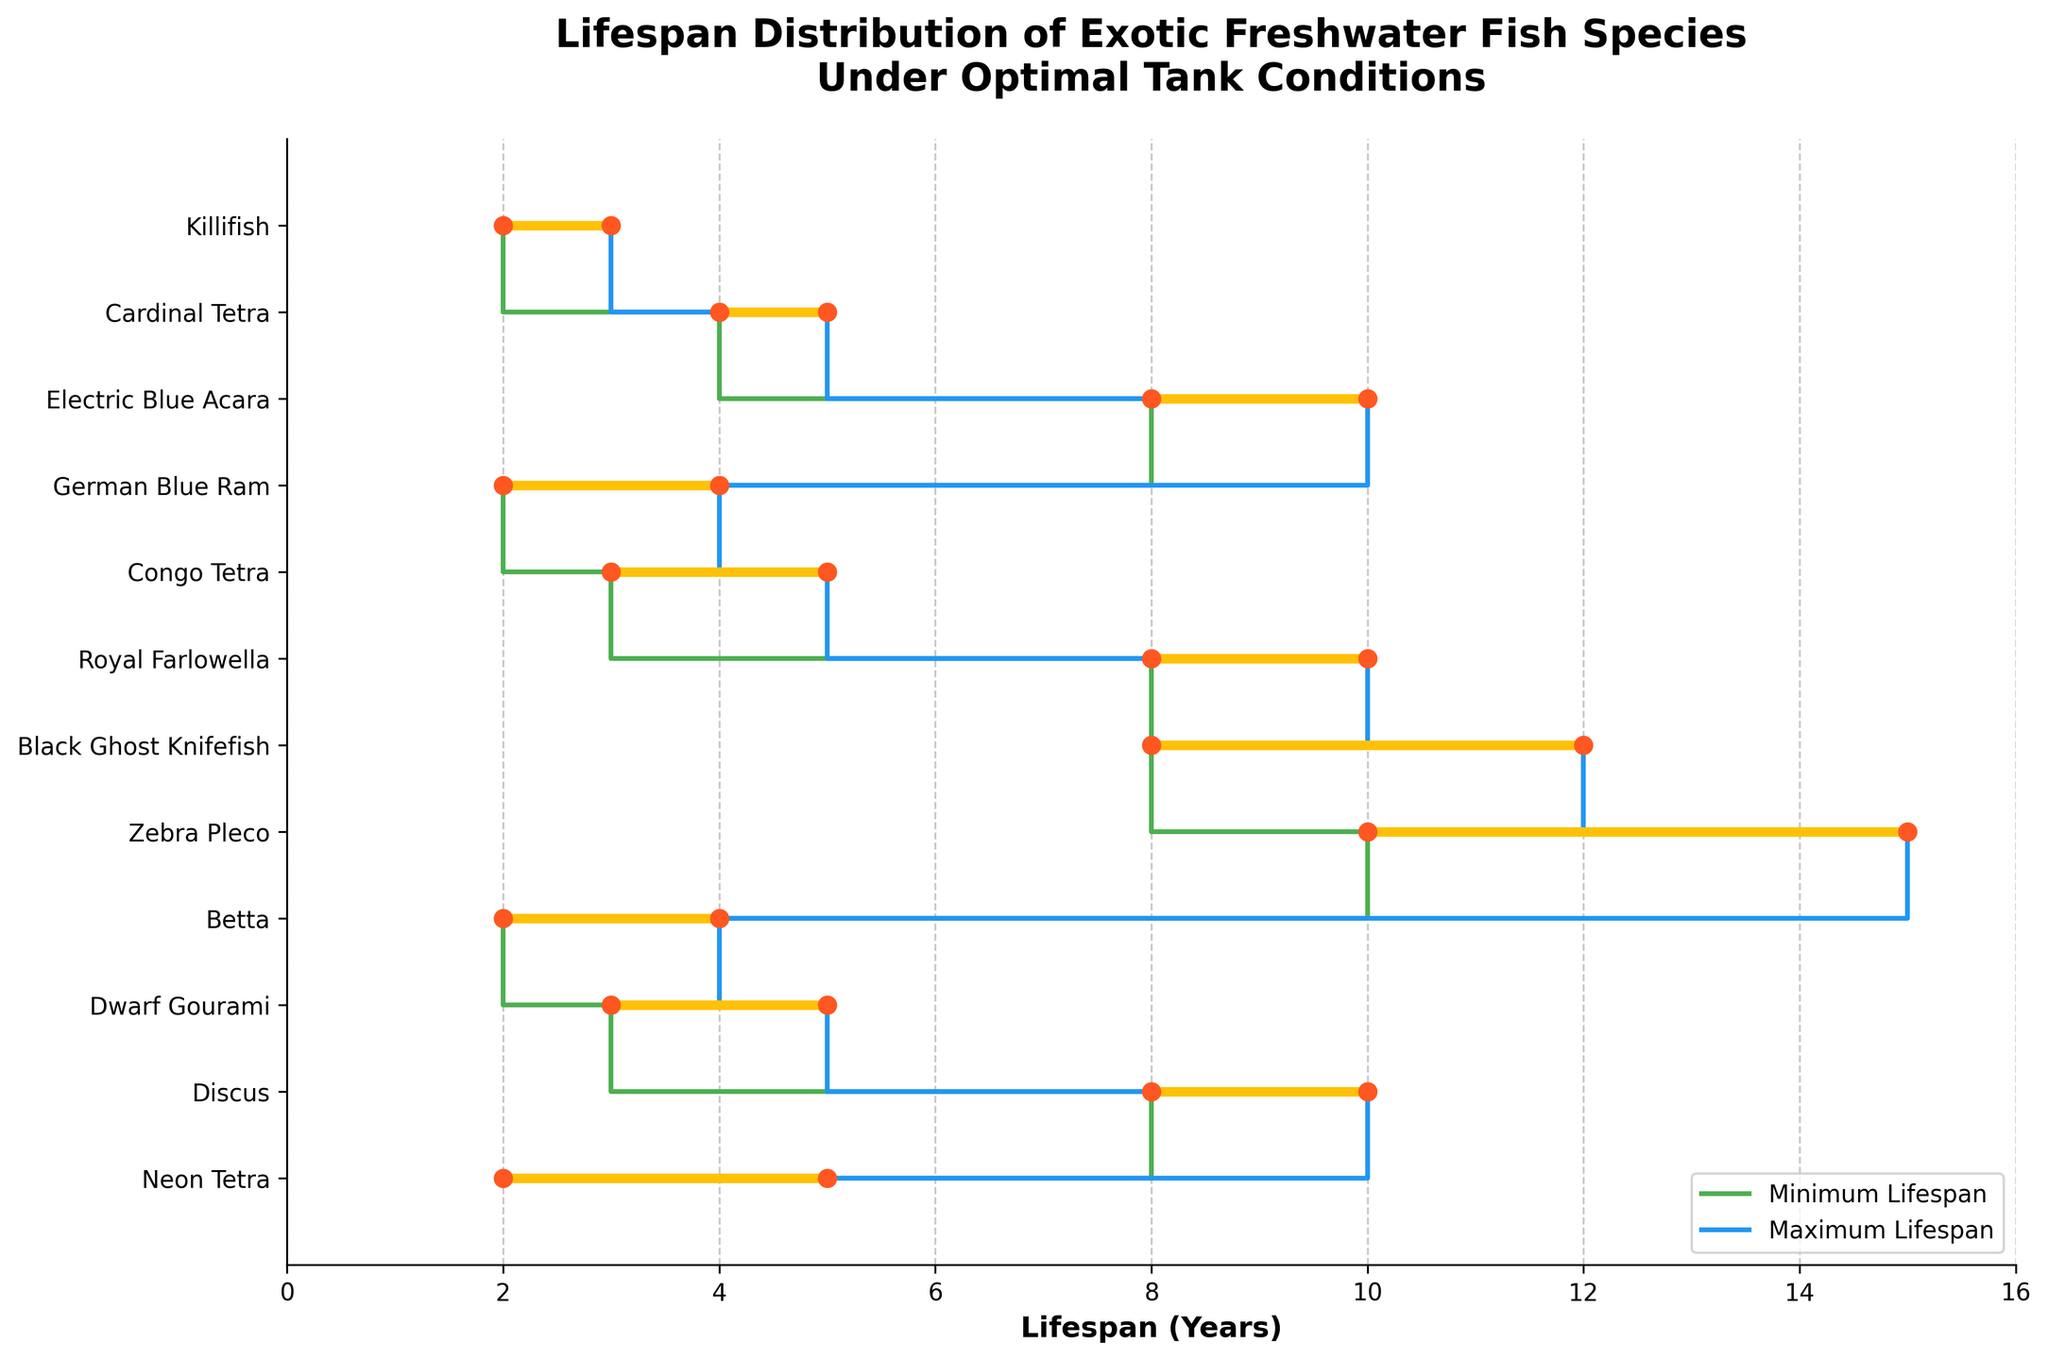What's the title of the plot? The title is displayed at the top of the plot and it reads 'Lifespan Distribution of Exotic Freshwater Fish Species Under Optimal Tank Conditions'. This provides context for the data being shown.
Answer: Lifespan Distribution of Exotic Freshwater Fish Species Under Optimal Tank Conditions How many species of fish are represented in the plot? Look at the number of labels on the y-axis. Each label corresponds to a different species of fish. There are 12 species listed.
Answer: 12 What is the maximum lifespan value shown on the x-axis? The x-axis represents the lifespan in years, and it has a numerical range. The highest value on this axis is 16.
Answer: 16 Which fish species has the shortest minimum lifespan? Check the green step line, which indicates the minimum lifespan for each species. Killifish has the shortest minimum lifespan, starting at 2 years.
Answer: Killifish Which fish species has the longest maximum lifespan? Observe the blue step line, representing the maximum lifespan. Zebra Pleco has the longest maximum lifespan, ending at 15 years.
Answer: Zebra Pleco What is the median of the minimum lifespans of all species? To find the median, list the minimum lifespans and find the middle value. The minimum lifespans are [2, 2, 2, 3, 3, 4, 8, 8, 8, 8, 10]. The median is the 6th value in this ordered list.
Answer: 4 How many species have a maximum lifespan of 10 years? Look at the species where the blue step ends at 10 years. Count these species: Discus, Royal Farlowella, Electric Blue Acara. There are 3 of them.
Answer: 3 Which species has the largest range in lifespan? Calculate the range (difference between maximum and minimum lifespan) for each species. Zebra Pleco has a range from 10 to 15 years, which is the largest.
Answer: Zebra Pleco Which two species have the most similar life spans? Compare the ranges for each pair of species. The Neon Tetra and Betta both start at 2 years and end at 5 and 4 years respectively, so their ranges are quite similar.
Answer: Neon Tetra and Betta What color line represents the maximum lifespan in this plot? The legend indicates the colors used for minimum and maximum lifespans. The blue line represents the maximum lifespan.
Answer: Blue 